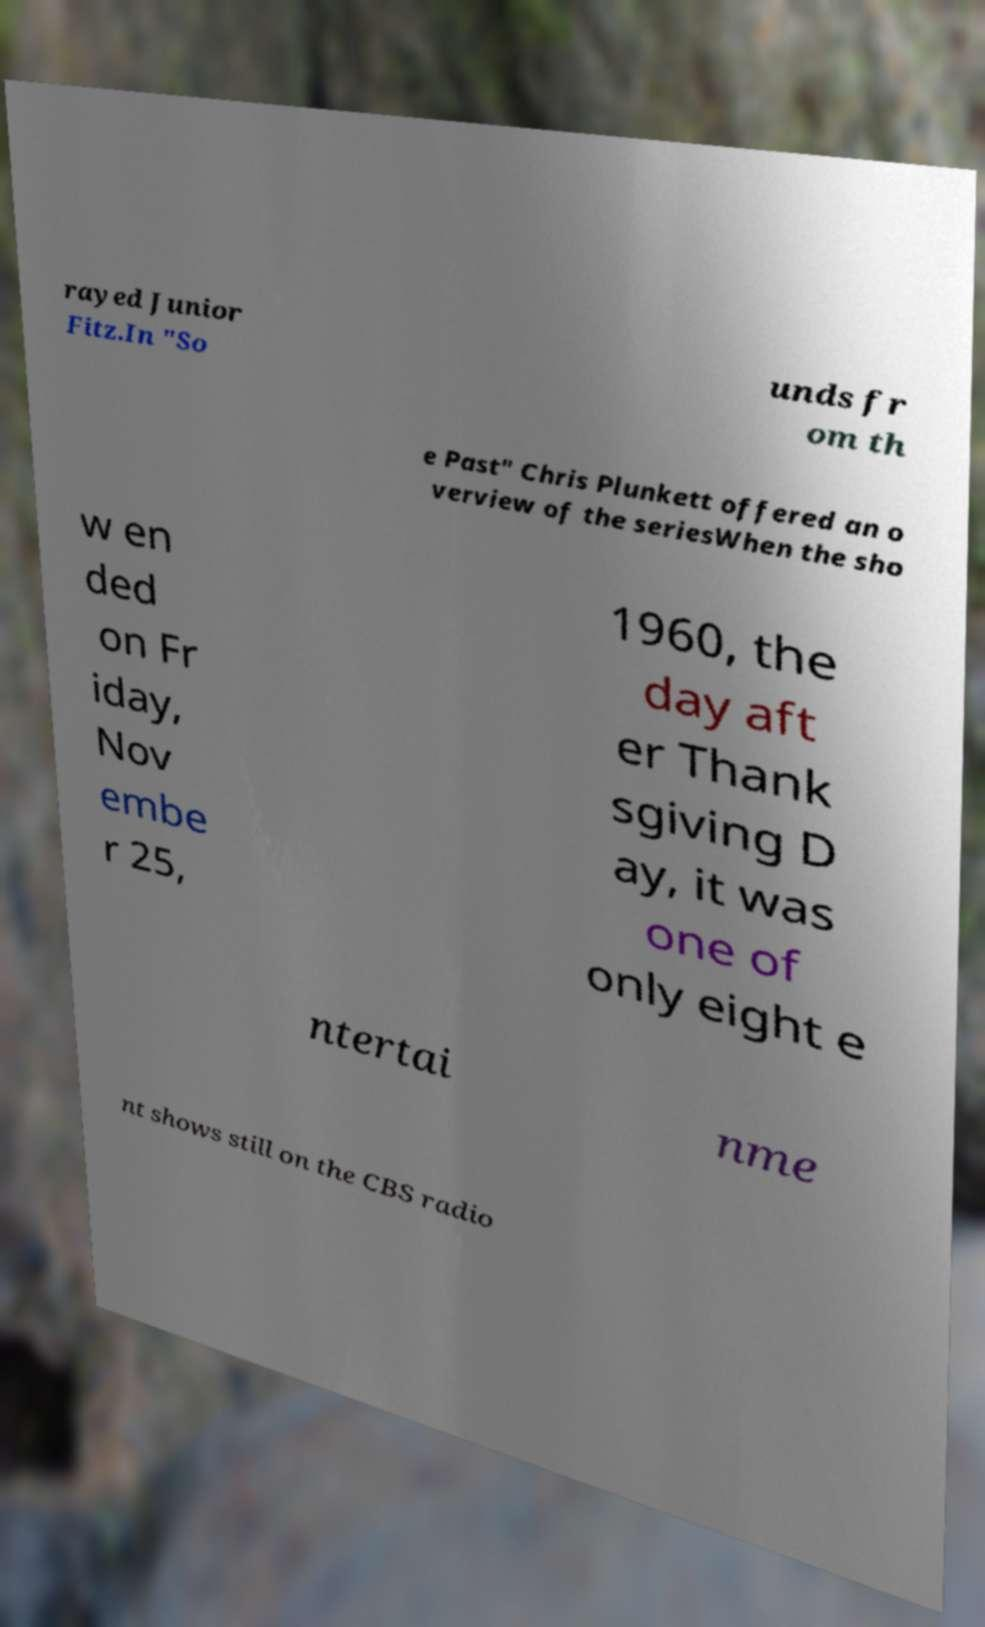Please identify and transcribe the text found in this image. rayed Junior Fitz.In "So unds fr om th e Past" Chris Plunkett offered an o verview of the seriesWhen the sho w en ded on Fr iday, Nov embe r 25, 1960, the day aft er Thank sgiving D ay, it was one of only eight e ntertai nme nt shows still on the CBS radio 